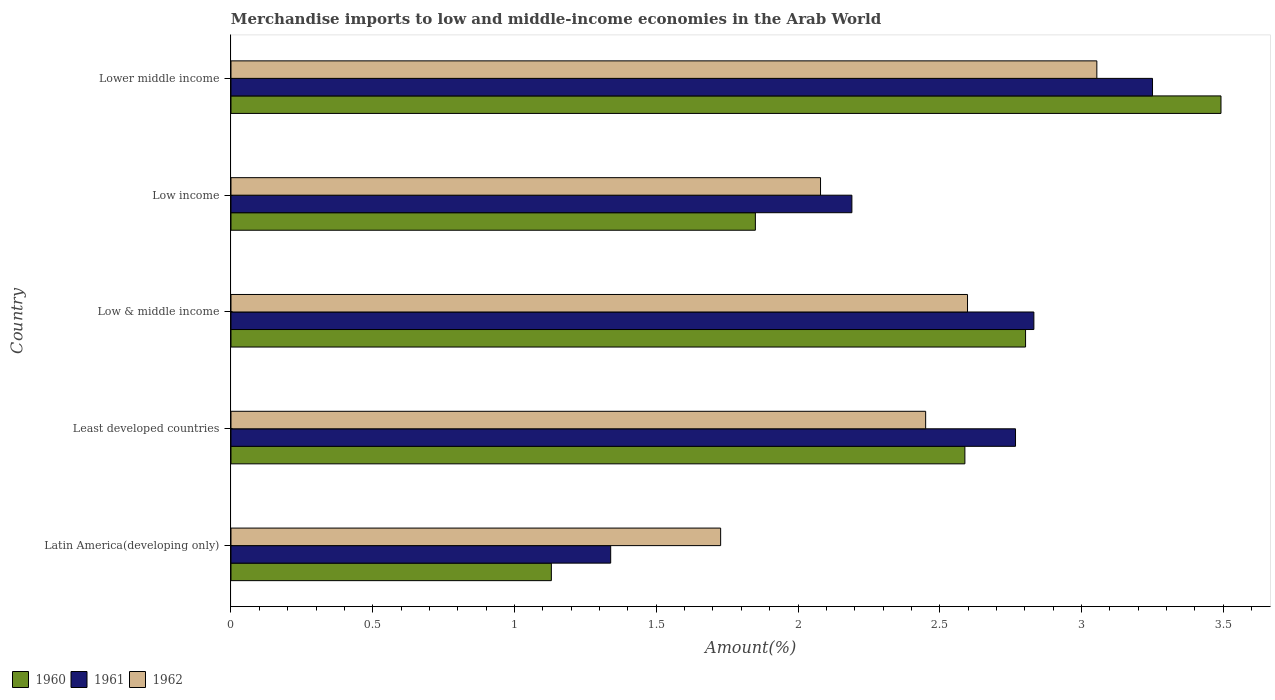Are the number of bars per tick equal to the number of legend labels?
Offer a very short reply. Yes. How many bars are there on the 3rd tick from the bottom?
Your answer should be compact. 3. In how many cases, is the number of bars for a given country not equal to the number of legend labels?
Your answer should be compact. 0. What is the percentage of amount earned from merchandise imports in 1962 in Least developed countries?
Your answer should be compact. 2.45. Across all countries, what is the maximum percentage of amount earned from merchandise imports in 1962?
Keep it short and to the point. 3.05. Across all countries, what is the minimum percentage of amount earned from merchandise imports in 1962?
Provide a succinct answer. 1.73. In which country was the percentage of amount earned from merchandise imports in 1961 maximum?
Provide a short and direct response. Lower middle income. In which country was the percentage of amount earned from merchandise imports in 1960 minimum?
Provide a succinct answer. Latin America(developing only). What is the total percentage of amount earned from merchandise imports in 1960 in the graph?
Offer a very short reply. 11.86. What is the difference between the percentage of amount earned from merchandise imports in 1961 in Low income and that in Lower middle income?
Offer a very short reply. -1.06. What is the difference between the percentage of amount earned from merchandise imports in 1961 in Lower middle income and the percentage of amount earned from merchandise imports in 1962 in Low income?
Keep it short and to the point. 1.17. What is the average percentage of amount earned from merchandise imports in 1961 per country?
Provide a short and direct response. 2.48. What is the difference between the percentage of amount earned from merchandise imports in 1962 and percentage of amount earned from merchandise imports in 1960 in Lower middle income?
Provide a short and direct response. -0.44. What is the ratio of the percentage of amount earned from merchandise imports in 1961 in Low & middle income to that in Lower middle income?
Provide a succinct answer. 0.87. What is the difference between the highest and the second highest percentage of amount earned from merchandise imports in 1960?
Give a very brief answer. 0.69. What is the difference between the highest and the lowest percentage of amount earned from merchandise imports in 1962?
Your response must be concise. 1.33. In how many countries, is the percentage of amount earned from merchandise imports in 1962 greater than the average percentage of amount earned from merchandise imports in 1962 taken over all countries?
Make the answer very short. 3. What does the 1st bar from the bottom in Lower middle income represents?
Ensure brevity in your answer.  1960. How many bars are there?
Give a very brief answer. 15. What is the difference between two consecutive major ticks on the X-axis?
Ensure brevity in your answer.  0.5. Are the values on the major ticks of X-axis written in scientific E-notation?
Ensure brevity in your answer.  No. Does the graph contain any zero values?
Ensure brevity in your answer.  No. How many legend labels are there?
Your answer should be compact. 3. How are the legend labels stacked?
Give a very brief answer. Horizontal. What is the title of the graph?
Offer a very short reply. Merchandise imports to low and middle-income economies in the Arab World. What is the label or title of the X-axis?
Ensure brevity in your answer.  Amount(%). What is the Amount(%) of 1960 in Latin America(developing only)?
Your answer should be compact. 1.13. What is the Amount(%) of 1961 in Latin America(developing only)?
Your answer should be very brief. 1.34. What is the Amount(%) of 1962 in Latin America(developing only)?
Make the answer very short. 1.73. What is the Amount(%) of 1960 in Least developed countries?
Your answer should be very brief. 2.59. What is the Amount(%) of 1961 in Least developed countries?
Ensure brevity in your answer.  2.77. What is the Amount(%) of 1962 in Least developed countries?
Your answer should be very brief. 2.45. What is the Amount(%) in 1960 in Low & middle income?
Offer a terse response. 2.8. What is the Amount(%) of 1961 in Low & middle income?
Your answer should be compact. 2.83. What is the Amount(%) in 1962 in Low & middle income?
Offer a very short reply. 2.6. What is the Amount(%) of 1960 in Low income?
Ensure brevity in your answer.  1.85. What is the Amount(%) of 1961 in Low income?
Offer a very short reply. 2.19. What is the Amount(%) of 1962 in Low income?
Make the answer very short. 2.08. What is the Amount(%) of 1960 in Lower middle income?
Provide a short and direct response. 3.49. What is the Amount(%) of 1961 in Lower middle income?
Your answer should be compact. 3.25. What is the Amount(%) in 1962 in Lower middle income?
Provide a succinct answer. 3.05. Across all countries, what is the maximum Amount(%) of 1960?
Your answer should be compact. 3.49. Across all countries, what is the maximum Amount(%) in 1961?
Ensure brevity in your answer.  3.25. Across all countries, what is the maximum Amount(%) in 1962?
Your response must be concise. 3.05. Across all countries, what is the minimum Amount(%) in 1960?
Give a very brief answer. 1.13. Across all countries, what is the minimum Amount(%) of 1961?
Offer a very short reply. 1.34. Across all countries, what is the minimum Amount(%) of 1962?
Your answer should be compact. 1.73. What is the total Amount(%) of 1960 in the graph?
Your answer should be very brief. 11.86. What is the total Amount(%) of 1961 in the graph?
Provide a short and direct response. 12.38. What is the total Amount(%) in 1962 in the graph?
Make the answer very short. 11.91. What is the difference between the Amount(%) of 1960 in Latin America(developing only) and that in Least developed countries?
Your answer should be compact. -1.46. What is the difference between the Amount(%) in 1961 in Latin America(developing only) and that in Least developed countries?
Ensure brevity in your answer.  -1.43. What is the difference between the Amount(%) in 1962 in Latin America(developing only) and that in Least developed countries?
Offer a very short reply. -0.72. What is the difference between the Amount(%) of 1960 in Latin America(developing only) and that in Low & middle income?
Ensure brevity in your answer.  -1.67. What is the difference between the Amount(%) of 1961 in Latin America(developing only) and that in Low & middle income?
Ensure brevity in your answer.  -1.49. What is the difference between the Amount(%) of 1962 in Latin America(developing only) and that in Low & middle income?
Provide a succinct answer. -0.87. What is the difference between the Amount(%) in 1960 in Latin America(developing only) and that in Low income?
Your response must be concise. -0.72. What is the difference between the Amount(%) in 1961 in Latin America(developing only) and that in Low income?
Your answer should be very brief. -0.85. What is the difference between the Amount(%) of 1962 in Latin America(developing only) and that in Low income?
Give a very brief answer. -0.35. What is the difference between the Amount(%) of 1960 in Latin America(developing only) and that in Lower middle income?
Your response must be concise. -2.36. What is the difference between the Amount(%) in 1961 in Latin America(developing only) and that in Lower middle income?
Offer a terse response. -1.91. What is the difference between the Amount(%) in 1962 in Latin America(developing only) and that in Lower middle income?
Your response must be concise. -1.33. What is the difference between the Amount(%) of 1960 in Least developed countries and that in Low & middle income?
Ensure brevity in your answer.  -0.21. What is the difference between the Amount(%) of 1961 in Least developed countries and that in Low & middle income?
Make the answer very short. -0.06. What is the difference between the Amount(%) of 1962 in Least developed countries and that in Low & middle income?
Your answer should be compact. -0.15. What is the difference between the Amount(%) in 1960 in Least developed countries and that in Low income?
Your response must be concise. 0.74. What is the difference between the Amount(%) of 1961 in Least developed countries and that in Low income?
Your answer should be compact. 0.58. What is the difference between the Amount(%) in 1962 in Least developed countries and that in Low income?
Your answer should be very brief. 0.37. What is the difference between the Amount(%) of 1960 in Least developed countries and that in Lower middle income?
Your answer should be compact. -0.9. What is the difference between the Amount(%) in 1961 in Least developed countries and that in Lower middle income?
Make the answer very short. -0.48. What is the difference between the Amount(%) of 1962 in Least developed countries and that in Lower middle income?
Offer a terse response. -0.6. What is the difference between the Amount(%) in 1960 in Low & middle income and that in Low income?
Your answer should be compact. 0.95. What is the difference between the Amount(%) in 1961 in Low & middle income and that in Low income?
Offer a very short reply. 0.64. What is the difference between the Amount(%) of 1962 in Low & middle income and that in Low income?
Offer a very short reply. 0.52. What is the difference between the Amount(%) in 1960 in Low & middle income and that in Lower middle income?
Your answer should be compact. -0.69. What is the difference between the Amount(%) of 1961 in Low & middle income and that in Lower middle income?
Your answer should be compact. -0.42. What is the difference between the Amount(%) of 1962 in Low & middle income and that in Lower middle income?
Your answer should be compact. -0.46. What is the difference between the Amount(%) of 1960 in Low income and that in Lower middle income?
Your response must be concise. -1.64. What is the difference between the Amount(%) in 1961 in Low income and that in Lower middle income?
Provide a short and direct response. -1.06. What is the difference between the Amount(%) of 1962 in Low income and that in Lower middle income?
Ensure brevity in your answer.  -0.97. What is the difference between the Amount(%) in 1960 in Latin America(developing only) and the Amount(%) in 1961 in Least developed countries?
Provide a short and direct response. -1.64. What is the difference between the Amount(%) of 1960 in Latin America(developing only) and the Amount(%) of 1962 in Least developed countries?
Keep it short and to the point. -1.32. What is the difference between the Amount(%) of 1961 in Latin America(developing only) and the Amount(%) of 1962 in Least developed countries?
Your response must be concise. -1.11. What is the difference between the Amount(%) of 1960 in Latin America(developing only) and the Amount(%) of 1961 in Low & middle income?
Your response must be concise. -1.7. What is the difference between the Amount(%) of 1960 in Latin America(developing only) and the Amount(%) of 1962 in Low & middle income?
Provide a succinct answer. -1.47. What is the difference between the Amount(%) of 1961 in Latin America(developing only) and the Amount(%) of 1962 in Low & middle income?
Your response must be concise. -1.26. What is the difference between the Amount(%) in 1960 in Latin America(developing only) and the Amount(%) in 1961 in Low income?
Ensure brevity in your answer.  -1.06. What is the difference between the Amount(%) of 1960 in Latin America(developing only) and the Amount(%) of 1962 in Low income?
Keep it short and to the point. -0.95. What is the difference between the Amount(%) in 1961 in Latin America(developing only) and the Amount(%) in 1962 in Low income?
Offer a very short reply. -0.74. What is the difference between the Amount(%) in 1960 in Latin America(developing only) and the Amount(%) in 1961 in Lower middle income?
Ensure brevity in your answer.  -2.12. What is the difference between the Amount(%) in 1960 in Latin America(developing only) and the Amount(%) in 1962 in Lower middle income?
Ensure brevity in your answer.  -1.92. What is the difference between the Amount(%) in 1961 in Latin America(developing only) and the Amount(%) in 1962 in Lower middle income?
Provide a short and direct response. -1.71. What is the difference between the Amount(%) in 1960 in Least developed countries and the Amount(%) in 1961 in Low & middle income?
Provide a short and direct response. -0.24. What is the difference between the Amount(%) of 1960 in Least developed countries and the Amount(%) of 1962 in Low & middle income?
Make the answer very short. -0.01. What is the difference between the Amount(%) of 1961 in Least developed countries and the Amount(%) of 1962 in Low & middle income?
Offer a very short reply. 0.17. What is the difference between the Amount(%) in 1960 in Least developed countries and the Amount(%) in 1961 in Low income?
Your answer should be very brief. 0.4. What is the difference between the Amount(%) of 1960 in Least developed countries and the Amount(%) of 1962 in Low income?
Give a very brief answer. 0.51. What is the difference between the Amount(%) of 1961 in Least developed countries and the Amount(%) of 1962 in Low income?
Your response must be concise. 0.69. What is the difference between the Amount(%) in 1960 in Least developed countries and the Amount(%) in 1961 in Lower middle income?
Your answer should be compact. -0.66. What is the difference between the Amount(%) of 1960 in Least developed countries and the Amount(%) of 1962 in Lower middle income?
Make the answer very short. -0.47. What is the difference between the Amount(%) of 1961 in Least developed countries and the Amount(%) of 1962 in Lower middle income?
Provide a succinct answer. -0.29. What is the difference between the Amount(%) in 1960 in Low & middle income and the Amount(%) in 1961 in Low income?
Provide a short and direct response. 0.61. What is the difference between the Amount(%) of 1960 in Low & middle income and the Amount(%) of 1962 in Low income?
Offer a very short reply. 0.72. What is the difference between the Amount(%) in 1961 in Low & middle income and the Amount(%) in 1962 in Low income?
Make the answer very short. 0.75. What is the difference between the Amount(%) in 1960 in Low & middle income and the Amount(%) in 1961 in Lower middle income?
Ensure brevity in your answer.  -0.45. What is the difference between the Amount(%) of 1960 in Low & middle income and the Amount(%) of 1962 in Lower middle income?
Give a very brief answer. -0.25. What is the difference between the Amount(%) in 1961 in Low & middle income and the Amount(%) in 1962 in Lower middle income?
Make the answer very short. -0.22. What is the difference between the Amount(%) of 1960 in Low income and the Amount(%) of 1961 in Lower middle income?
Give a very brief answer. -1.4. What is the difference between the Amount(%) of 1960 in Low income and the Amount(%) of 1962 in Lower middle income?
Your response must be concise. -1.2. What is the difference between the Amount(%) in 1961 in Low income and the Amount(%) in 1962 in Lower middle income?
Keep it short and to the point. -0.86. What is the average Amount(%) of 1960 per country?
Your answer should be very brief. 2.37. What is the average Amount(%) in 1961 per country?
Keep it short and to the point. 2.48. What is the average Amount(%) in 1962 per country?
Provide a short and direct response. 2.38. What is the difference between the Amount(%) in 1960 and Amount(%) in 1961 in Latin America(developing only)?
Offer a very short reply. -0.21. What is the difference between the Amount(%) of 1960 and Amount(%) of 1962 in Latin America(developing only)?
Your answer should be very brief. -0.6. What is the difference between the Amount(%) of 1961 and Amount(%) of 1962 in Latin America(developing only)?
Offer a terse response. -0.39. What is the difference between the Amount(%) of 1960 and Amount(%) of 1961 in Least developed countries?
Your answer should be very brief. -0.18. What is the difference between the Amount(%) in 1960 and Amount(%) in 1962 in Least developed countries?
Ensure brevity in your answer.  0.14. What is the difference between the Amount(%) in 1961 and Amount(%) in 1962 in Least developed countries?
Provide a short and direct response. 0.32. What is the difference between the Amount(%) of 1960 and Amount(%) of 1961 in Low & middle income?
Your answer should be very brief. -0.03. What is the difference between the Amount(%) in 1960 and Amount(%) in 1962 in Low & middle income?
Your answer should be compact. 0.2. What is the difference between the Amount(%) in 1961 and Amount(%) in 1962 in Low & middle income?
Make the answer very short. 0.23. What is the difference between the Amount(%) in 1960 and Amount(%) in 1961 in Low income?
Provide a succinct answer. -0.34. What is the difference between the Amount(%) in 1960 and Amount(%) in 1962 in Low income?
Provide a succinct answer. -0.23. What is the difference between the Amount(%) in 1961 and Amount(%) in 1962 in Low income?
Your answer should be compact. 0.11. What is the difference between the Amount(%) of 1960 and Amount(%) of 1961 in Lower middle income?
Provide a succinct answer. 0.24. What is the difference between the Amount(%) in 1960 and Amount(%) in 1962 in Lower middle income?
Ensure brevity in your answer.  0.44. What is the difference between the Amount(%) in 1961 and Amount(%) in 1962 in Lower middle income?
Give a very brief answer. 0.2. What is the ratio of the Amount(%) of 1960 in Latin America(developing only) to that in Least developed countries?
Your answer should be compact. 0.44. What is the ratio of the Amount(%) in 1961 in Latin America(developing only) to that in Least developed countries?
Ensure brevity in your answer.  0.48. What is the ratio of the Amount(%) in 1962 in Latin America(developing only) to that in Least developed countries?
Ensure brevity in your answer.  0.7. What is the ratio of the Amount(%) of 1960 in Latin America(developing only) to that in Low & middle income?
Make the answer very short. 0.4. What is the ratio of the Amount(%) of 1961 in Latin America(developing only) to that in Low & middle income?
Provide a short and direct response. 0.47. What is the ratio of the Amount(%) of 1962 in Latin America(developing only) to that in Low & middle income?
Make the answer very short. 0.66. What is the ratio of the Amount(%) of 1960 in Latin America(developing only) to that in Low income?
Your response must be concise. 0.61. What is the ratio of the Amount(%) of 1961 in Latin America(developing only) to that in Low income?
Offer a terse response. 0.61. What is the ratio of the Amount(%) in 1962 in Latin America(developing only) to that in Low income?
Your response must be concise. 0.83. What is the ratio of the Amount(%) of 1960 in Latin America(developing only) to that in Lower middle income?
Provide a succinct answer. 0.32. What is the ratio of the Amount(%) in 1961 in Latin America(developing only) to that in Lower middle income?
Ensure brevity in your answer.  0.41. What is the ratio of the Amount(%) of 1962 in Latin America(developing only) to that in Lower middle income?
Make the answer very short. 0.57. What is the ratio of the Amount(%) in 1960 in Least developed countries to that in Low & middle income?
Offer a terse response. 0.92. What is the ratio of the Amount(%) of 1961 in Least developed countries to that in Low & middle income?
Provide a short and direct response. 0.98. What is the ratio of the Amount(%) of 1962 in Least developed countries to that in Low & middle income?
Your response must be concise. 0.94. What is the ratio of the Amount(%) in 1960 in Least developed countries to that in Low income?
Offer a very short reply. 1.4. What is the ratio of the Amount(%) in 1961 in Least developed countries to that in Low income?
Your response must be concise. 1.26. What is the ratio of the Amount(%) in 1962 in Least developed countries to that in Low income?
Provide a succinct answer. 1.18. What is the ratio of the Amount(%) in 1960 in Least developed countries to that in Lower middle income?
Keep it short and to the point. 0.74. What is the ratio of the Amount(%) in 1961 in Least developed countries to that in Lower middle income?
Your answer should be very brief. 0.85. What is the ratio of the Amount(%) of 1962 in Least developed countries to that in Lower middle income?
Give a very brief answer. 0.8. What is the ratio of the Amount(%) in 1960 in Low & middle income to that in Low income?
Provide a succinct answer. 1.52. What is the ratio of the Amount(%) in 1961 in Low & middle income to that in Low income?
Give a very brief answer. 1.29. What is the ratio of the Amount(%) of 1962 in Low & middle income to that in Low income?
Offer a terse response. 1.25. What is the ratio of the Amount(%) of 1960 in Low & middle income to that in Lower middle income?
Make the answer very short. 0.8. What is the ratio of the Amount(%) of 1961 in Low & middle income to that in Lower middle income?
Offer a very short reply. 0.87. What is the ratio of the Amount(%) of 1962 in Low & middle income to that in Lower middle income?
Make the answer very short. 0.85. What is the ratio of the Amount(%) in 1960 in Low income to that in Lower middle income?
Make the answer very short. 0.53. What is the ratio of the Amount(%) of 1961 in Low income to that in Lower middle income?
Make the answer very short. 0.67. What is the ratio of the Amount(%) in 1962 in Low income to that in Lower middle income?
Ensure brevity in your answer.  0.68. What is the difference between the highest and the second highest Amount(%) in 1960?
Ensure brevity in your answer.  0.69. What is the difference between the highest and the second highest Amount(%) of 1961?
Make the answer very short. 0.42. What is the difference between the highest and the second highest Amount(%) in 1962?
Your answer should be compact. 0.46. What is the difference between the highest and the lowest Amount(%) in 1960?
Your answer should be very brief. 2.36. What is the difference between the highest and the lowest Amount(%) in 1961?
Make the answer very short. 1.91. What is the difference between the highest and the lowest Amount(%) in 1962?
Ensure brevity in your answer.  1.33. 